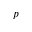<formula> <loc_0><loc_0><loc_500><loc_500>p</formula> 